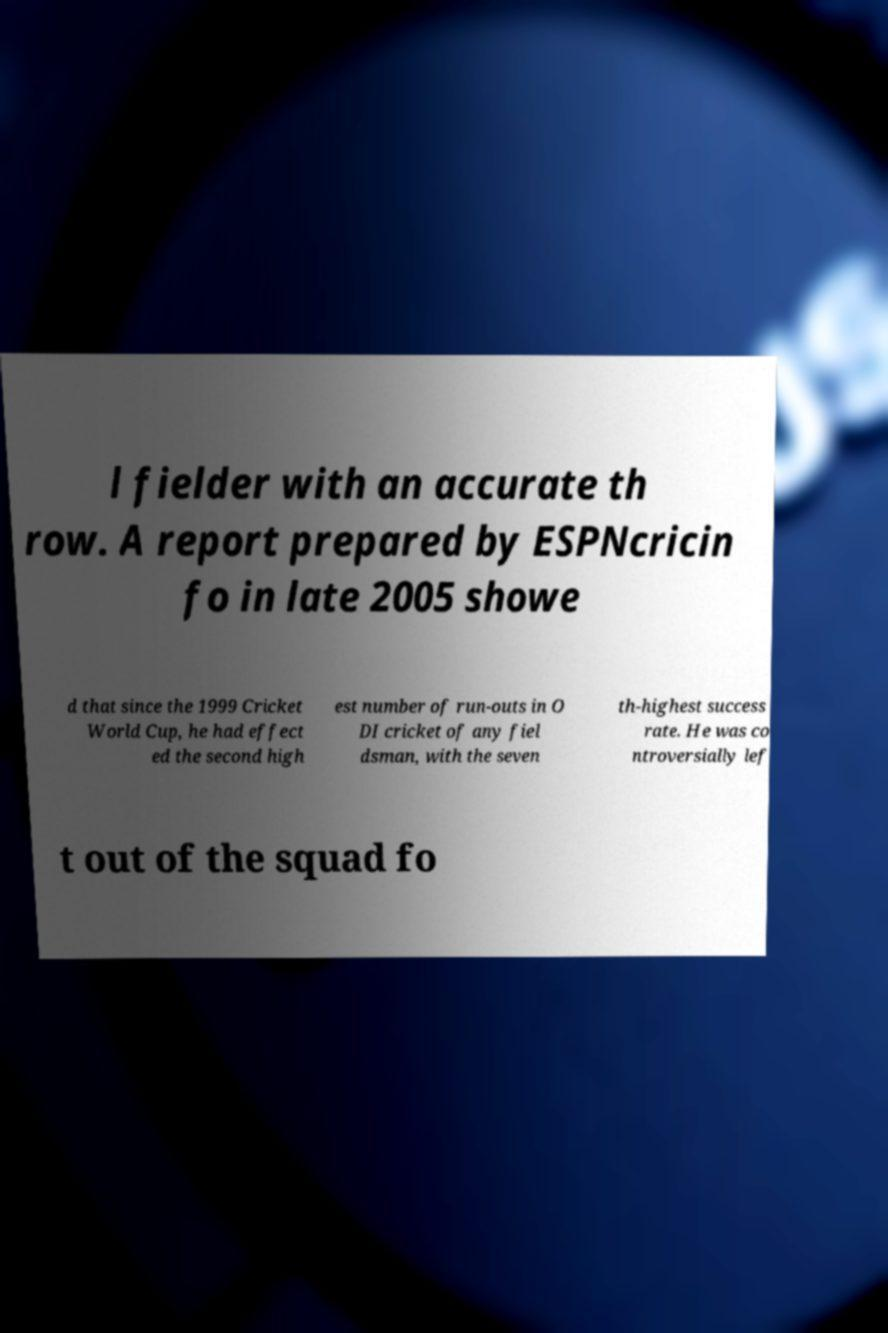I need the written content from this picture converted into text. Can you do that? l fielder with an accurate th row. A report prepared by ESPNcricin fo in late 2005 showe d that since the 1999 Cricket World Cup, he had effect ed the second high est number of run-outs in O DI cricket of any fiel dsman, with the seven th-highest success rate. He was co ntroversially lef t out of the squad fo 